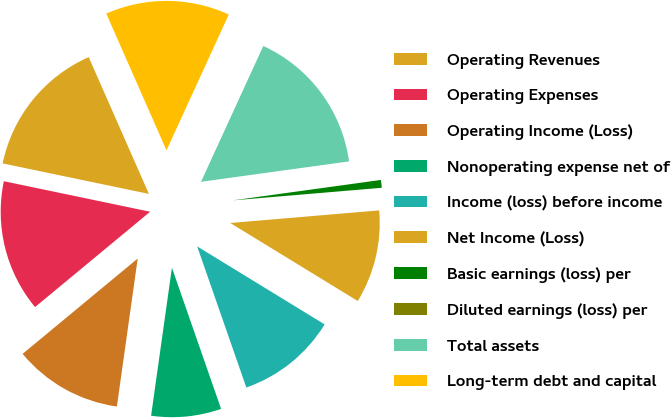Convert chart to OTSL. <chart><loc_0><loc_0><loc_500><loc_500><pie_chart><fcel>Operating Revenues<fcel>Operating Expenses<fcel>Operating Income (Loss)<fcel>Nonoperating expense net of<fcel>Income (loss) before income<fcel>Net Income (Loss)<fcel>Basic earnings (loss) per<fcel>Diluted earnings (loss) per<fcel>Total assets<fcel>Long-term debt and capital<nl><fcel>15.12%<fcel>14.28%<fcel>11.76%<fcel>7.56%<fcel>10.92%<fcel>10.08%<fcel>0.84%<fcel>0.0%<fcel>15.97%<fcel>13.44%<nl></chart> 